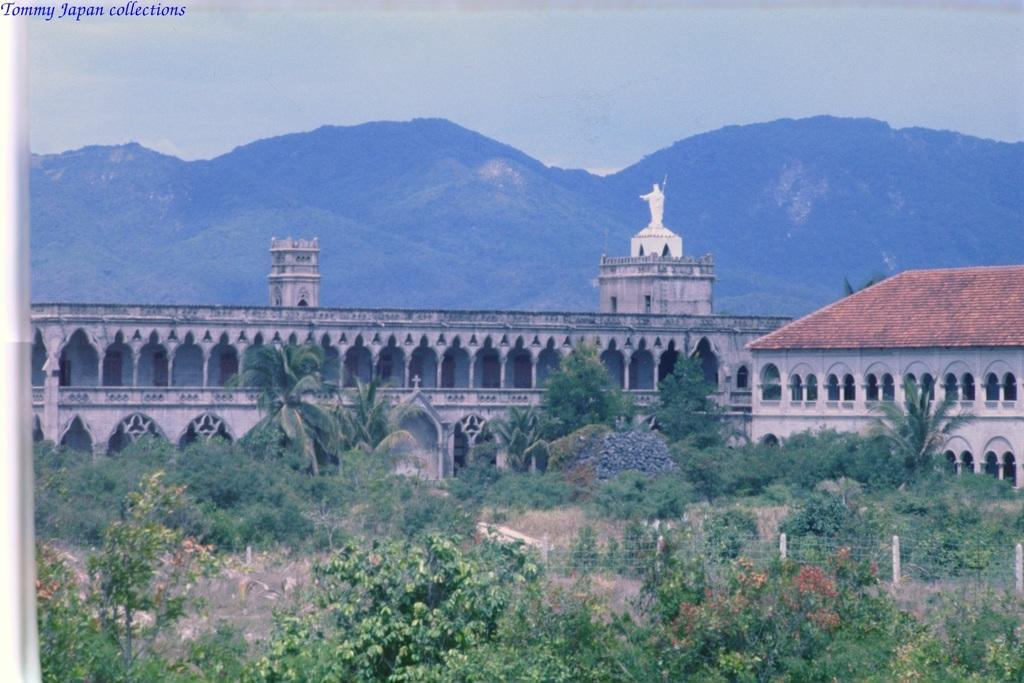What type of vegetation can be seen in the image? There are trees in the image. What structures are present in the image? There are fences, buildings, and statues in the image. What type of ground cover is visible in the image? There is lawn straw in the image. What natural features can be seen in the image? There are hills in the image. What part of the natural environment is visible in the image? The sky is visible in the image. What type of silk material is draped over the knee of the statue in the image? There is no silk material draped over the knee of any statue in the image. What type of pets can be seen playing in the grass in the image? There are no pets visible in the image. 